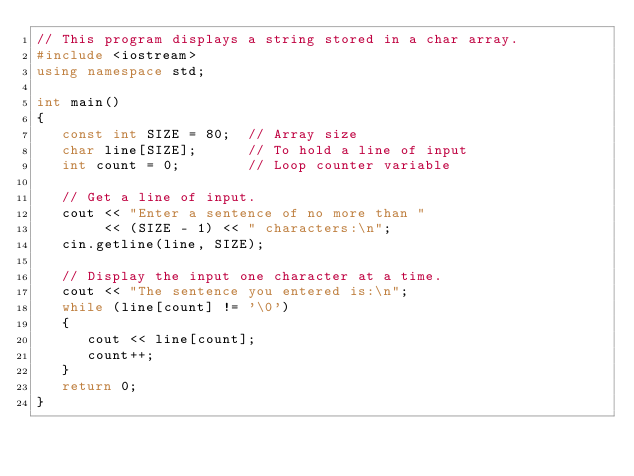Convert code to text. <code><loc_0><loc_0><loc_500><loc_500><_C++_>// This program displays a string stored in a char array.
#include <iostream>
using namespace std;

int main()
{
   const int SIZE = 80;  // Array size
   char line[SIZE];      // To hold a line of input
   int count = 0;        // Loop counter variable

   // Get a line of input.
   cout << "Enter a sentence of no more than " 
        << (SIZE - 1) << " characters:\n";
   cin.getline(line, SIZE);
   
   // Display the input one character at a time.
   cout << "The sentence you entered is:\n";
   while (line[count] != '\0')
   {
      cout << line[count];
      count++;
   }
   return 0;
}</code> 